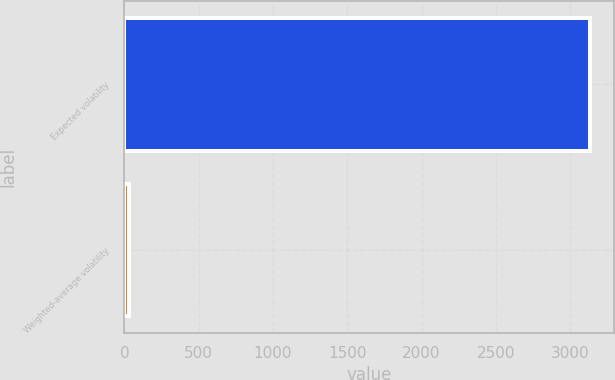Convert chart to OTSL. <chart><loc_0><loc_0><loc_500><loc_500><bar_chart><fcel>Expected volatility<fcel>Weighted-average volatility<nl><fcel>3137<fcel>33<nl></chart> 